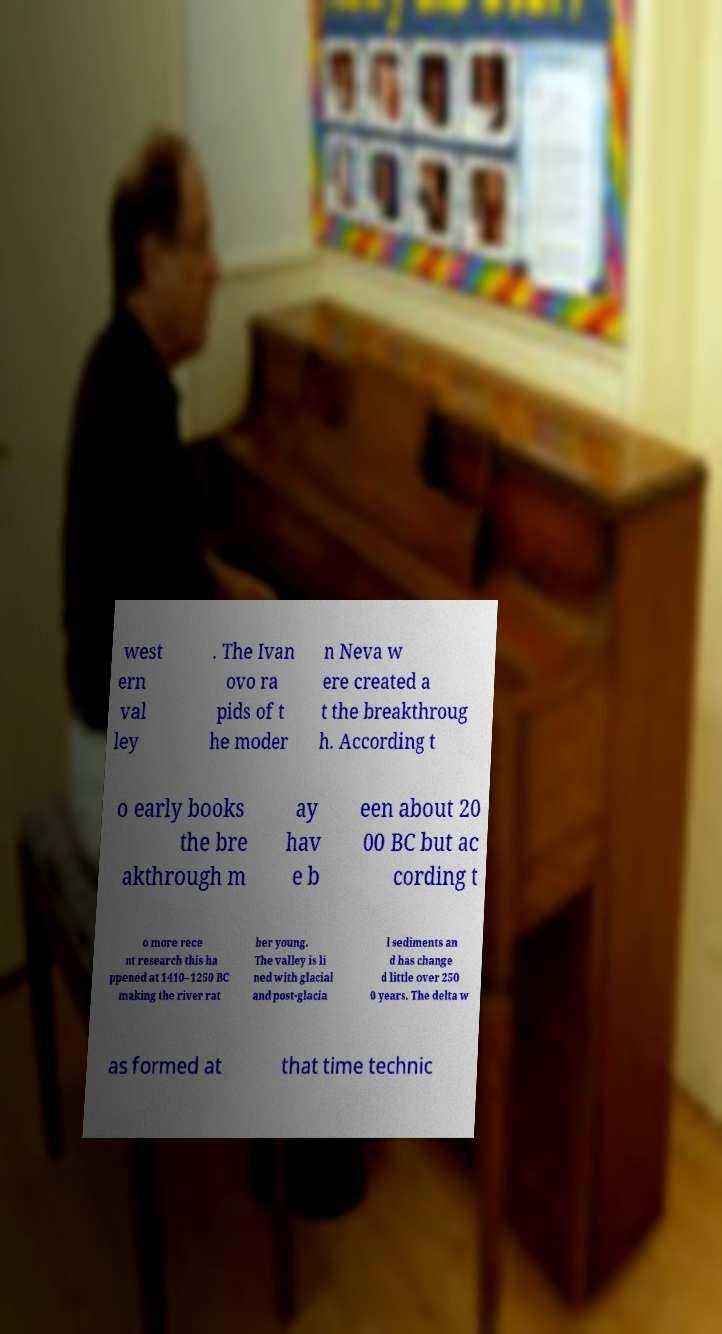There's text embedded in this image that I need extracted. Can you transcribe it verbatim? west ern val ley . The Ivan ovo ra pids of t he moder n Neva w ere created a t the breakthroug h. According t o early books the bre akthrough m ay hav e b een about 20 00 BC but ac cording t o more rece nt research this ha ppened at 1410–1250 BC making the river rat her young. The valley is li ned with glacial and post-glacia l sediments an d has change d little over 250 0 years. The delta w as formed at that time technic 